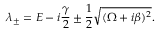Convert formula to latex. <formula><loc_0><loc_0><loc_500><loc_500>\lambda _ { \pm } = E - i \frac { \gamma } { 2 } \pm \frac { 1 } { 2 } \sqrt { ( \Omega + i \beta ) ^ { 2 } } .</formula> 